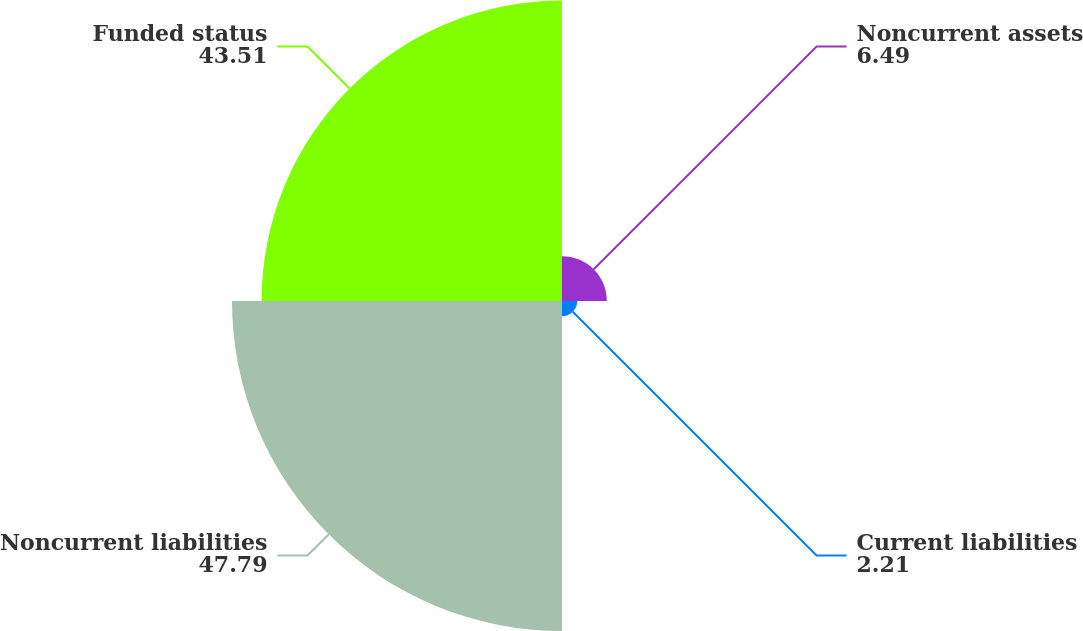Convert chart. <chart><loc_0><loc_0><loc_500><loc_500><pie_chart><fcel>Noncurrent assets<fcel>Current liabilities<fcel>Noncurrent liabilities<fcel>Funded status<nl><fcel>6.49%<fcel>2.21%<fcel>47.79%<fcel>43.51%<nl></chart> 